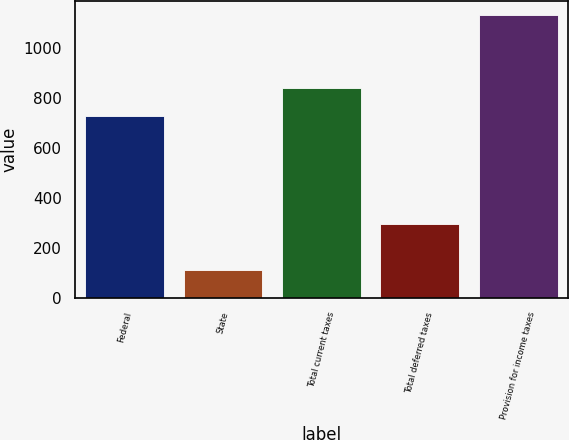Convert chart. <chart><loc_0><loc_0><loc_500><loc_500><bar_chart><fcel>Federal<fcel>State<fcel>Total current taxes<fcel>Total deferred taxes<fcel>Provision for income taxes<nl><fcel>729<fcel>111<fcel>840<fcel>294<fcel>1134<nl></chart> 